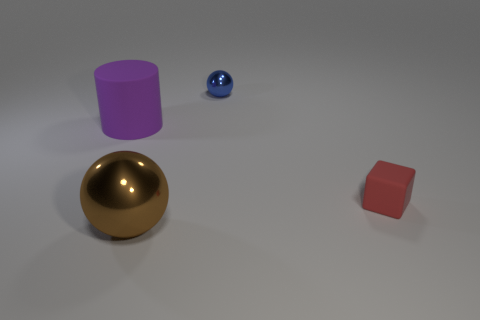What materials do the objects in the image appear to be made of? The sphere has a reflective surface that suggests it could be made of a polished metal or a glossy plastic. The cylinder looks matte, possibly indicating a surface like painted wood or plastic. The golden sphere's shiny texture implies a metallic material, and the red cube also appears matte, akin to the cylinder. 